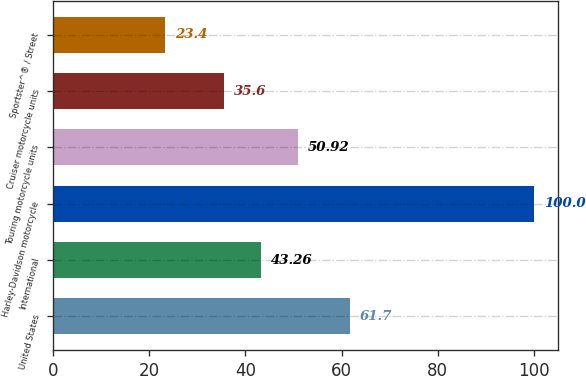Convert chart. <chart><loc_0><loc_0><loc_500><loc_500><bar_chart><fcel>United States<fcel>International<fcel>Harley-Davidson motorcycle<fcel>Touring motorcycle units<fcel>Cruiser motorcycle units<fcel>Sportster^® / Street<nl><fcel>61.7<fcel>43.26<fcel>100<fcel>50.92<fcel>35.6<fcel>23.4<nl></chart> 